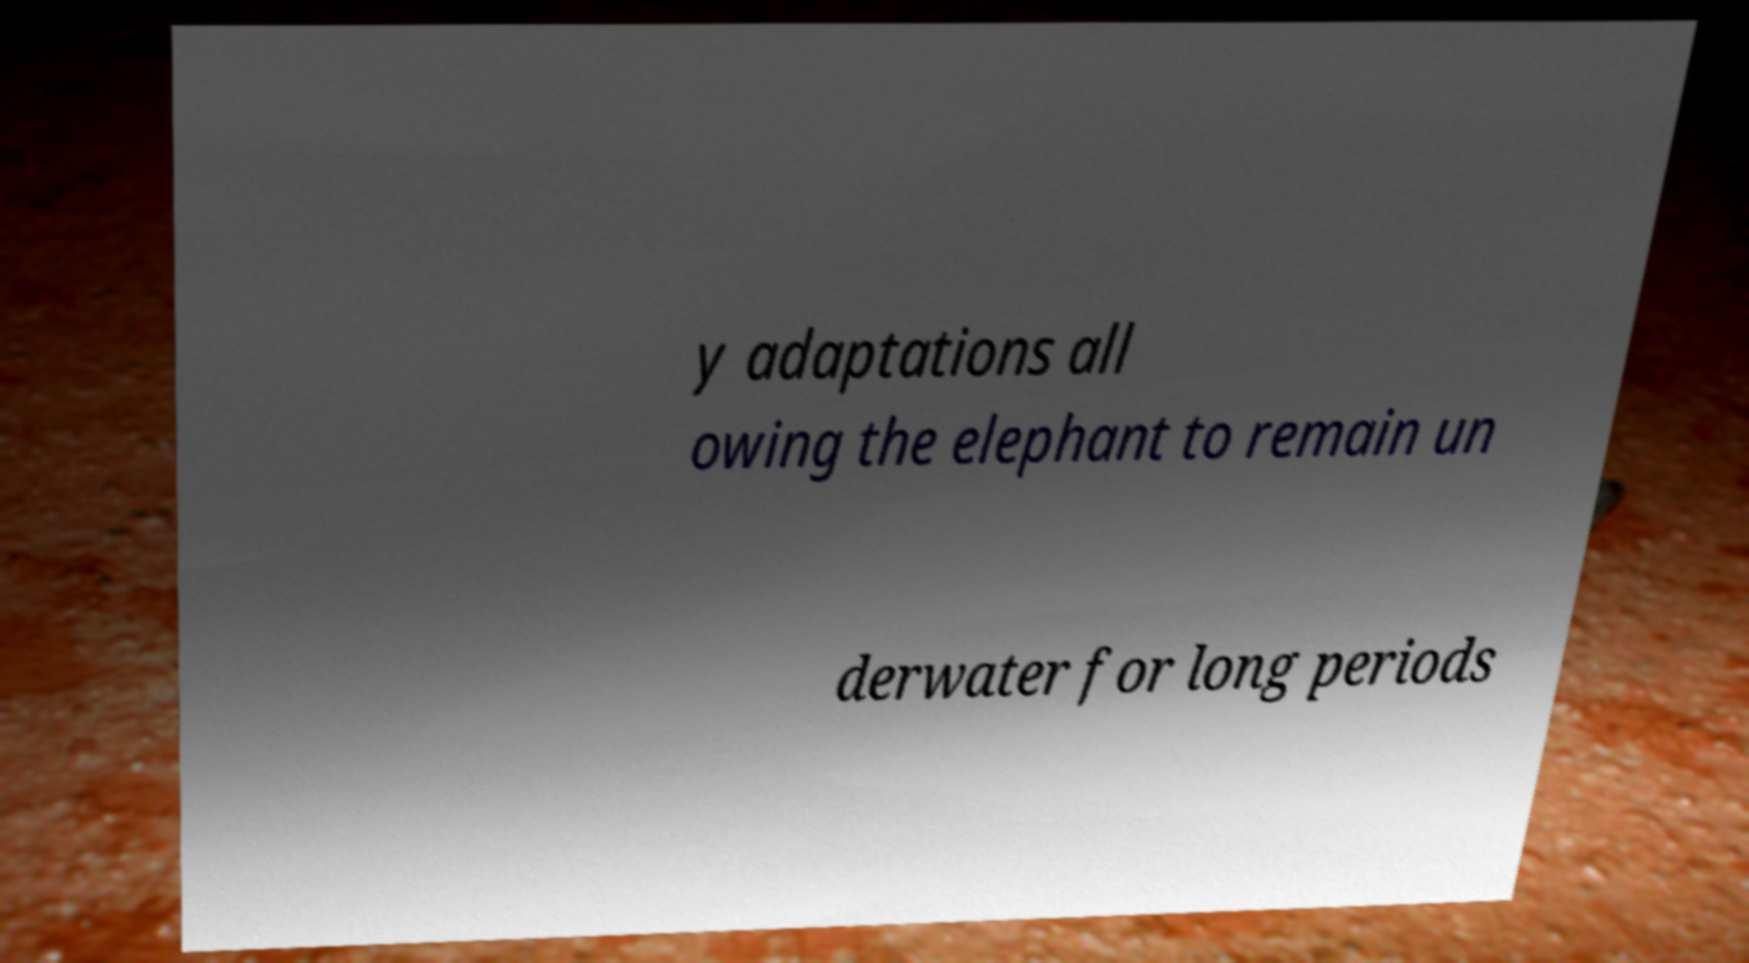I need the written content from this picture converted into text. Can you do that? y adaptations all owing the elephant to remain un derwater for long periods 